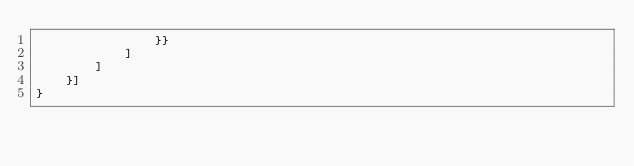<code> <loc_0><loc_0><loc_500><loc_500><_Python_>                }}
            ]
        ]
    }]        
}
</code> 